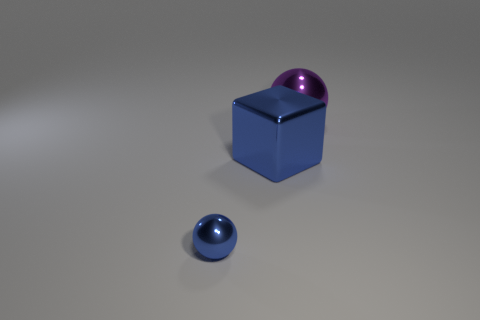Add 3 big purple metal cubes. How many objects exist? 6 Subtract 2 balls. How many balls are left? 0 Subtract all spheres. How many objects are left? 1 Add 1 purple shiny spheres. How many purple shiny spheres are left? 2 Add 2 large shiny objects. How many large shiny objects exist? 4 Subtract 0 cyan spheres. How many objects are left? 3 Subtract all cyan spheres. Subtract all green cubes. How many spheres are left? 2 Subtract all purple shiny cylinders. Subtract all small objects. How many objects are left? 2 